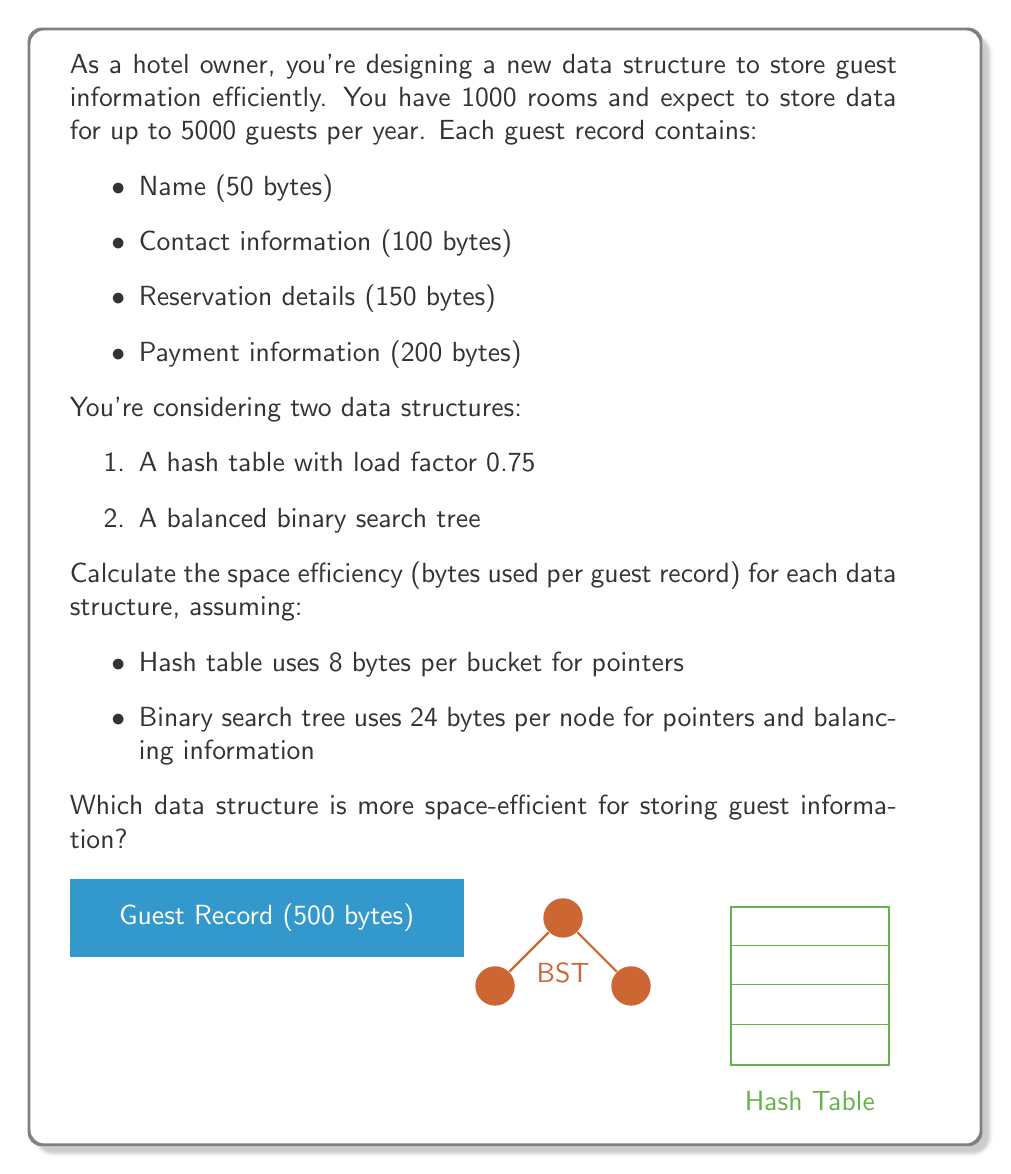Teach me how to tackle this problem. Let's analyze the space efficiency of both data structures step by step:

1. Calculate the size of each guest record:
   $$ \text{Record size} = 50 + 100 + 150 + 200 = 500 \text{ bytes} $$

2. Hash Table analysis:
   a. Number of buckets needed:
      $$ \text{Buckets} = \frac{\text{Number of guests}}{\text{Load factor}} = \frac{5000}{0.75} = 6667 \text{ buckets} $$
   b. Space for buckets:
      $$ \text{Bucket space} = 6667 \times 8 = 53,336 \text{ bytes} $$
   c. Total space:
      $$ \text{Total space} = (500 \times 5000) + 53,336 = 2,553,336 \text{ bytes} $$
   d. Space efficiency:
      $$ \text{Efficiency}_{\text{hash}} = \frac{2,553,336}{5000} = 510.6672 \text{ bytes/guest} $$

3. Balanced Binary Search Tree analysis:
   a. Space for nodes:
      $$ \text{Node space} = 5000 \times 24 = 120,000 \text{ bytes} $$
   b. Total space:
      $$ \text{Total space} = (500 \times 5000) + 120,000 = 2,620,000 \text{ bytes} $$
   c. Space efficiency:
      $$ \text{Efficiency}_{\text{BST}} = \frac{2,620,000}{5000} = 524 \text{ bytes/guest} $$

4. Comparing efficiencies:
   The hash table uses 510.6672 bytes/guest, while the BST uses 524 bytes/guest.
   $$ 510.6672 < 524 $$

Therefore, the hash table is more space-efficient for storing guest information.
Answer: Hash table (510.6672 bytes/guest) 